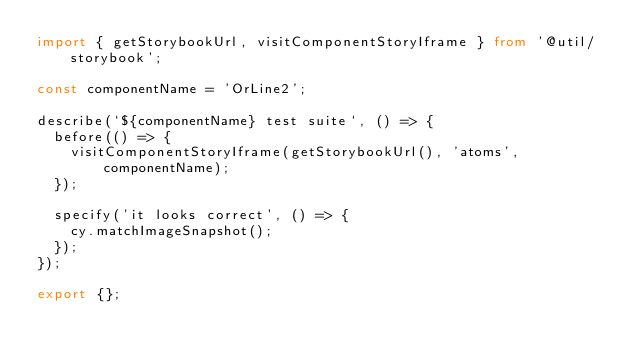<code> <loc_0><loc_0><loc_500><loc_500><_TypeScript_>import { getStorybookUrl, visitComponentStoryIframe } from '@util/storybook';

const componentName = 'OrLine2';

describe(`${componentName} test suite`, () => {
  before(() => {
    visitComponentStoryIframe(getStorybookUrl(), 'atoms', componentName);
  });

  specify('it looks correct', () => {
    cy.matchImageSnapshot();
  });
});

export {};
</code> 